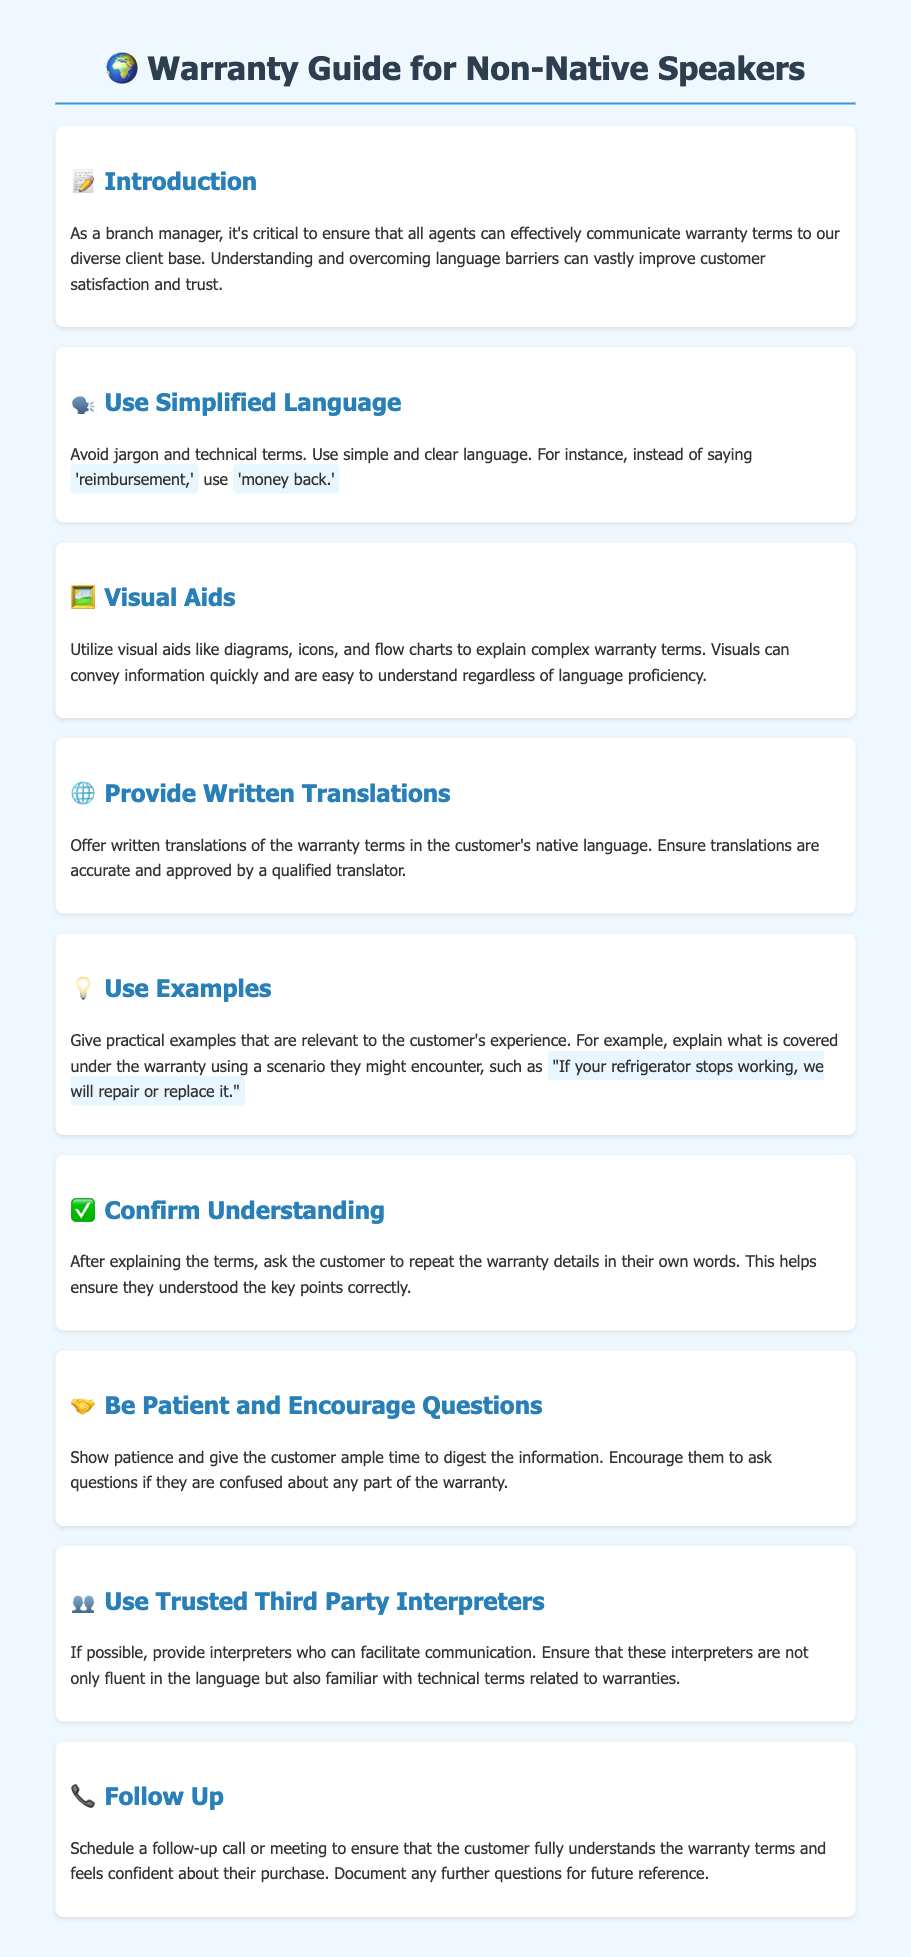what is the purpose of the guide? The guide aims to help agents effectively communicate warranty terms to a diverse client base.
Answer: improve communication what should agents avoid when explaining warranty terms? Agents should avoid using jargon and technical terms to ensure clarity.
Answer: jargon what is recommended to help explain complex warranty terms? Using visual aids like diagrams, icons, and flow charts can help clarify complex terms.
Answer: visual aids what should written translations of warranty terms be? Written translations should be accurate and approved by a qualified translator.
Answer: accurate what should agents confirm after explaining the warranty terms? Agents should ask customers to repeat the warranty details in their own words.
Answer: understanding why should agents encourage questions from customers? Encouraging questions allows customers to clarify any confusion about the warranty.
Answer: confusion who should facilitate communication if language barriers exist? Trusted third party interpreters who are fluent and familiar with technical terms should assist.
Answer: interpreters what should agents schedule after explaining warranty terms? Agents should schedule a follow-up call or meeting to ensure understanding.
Answer: follow-up 